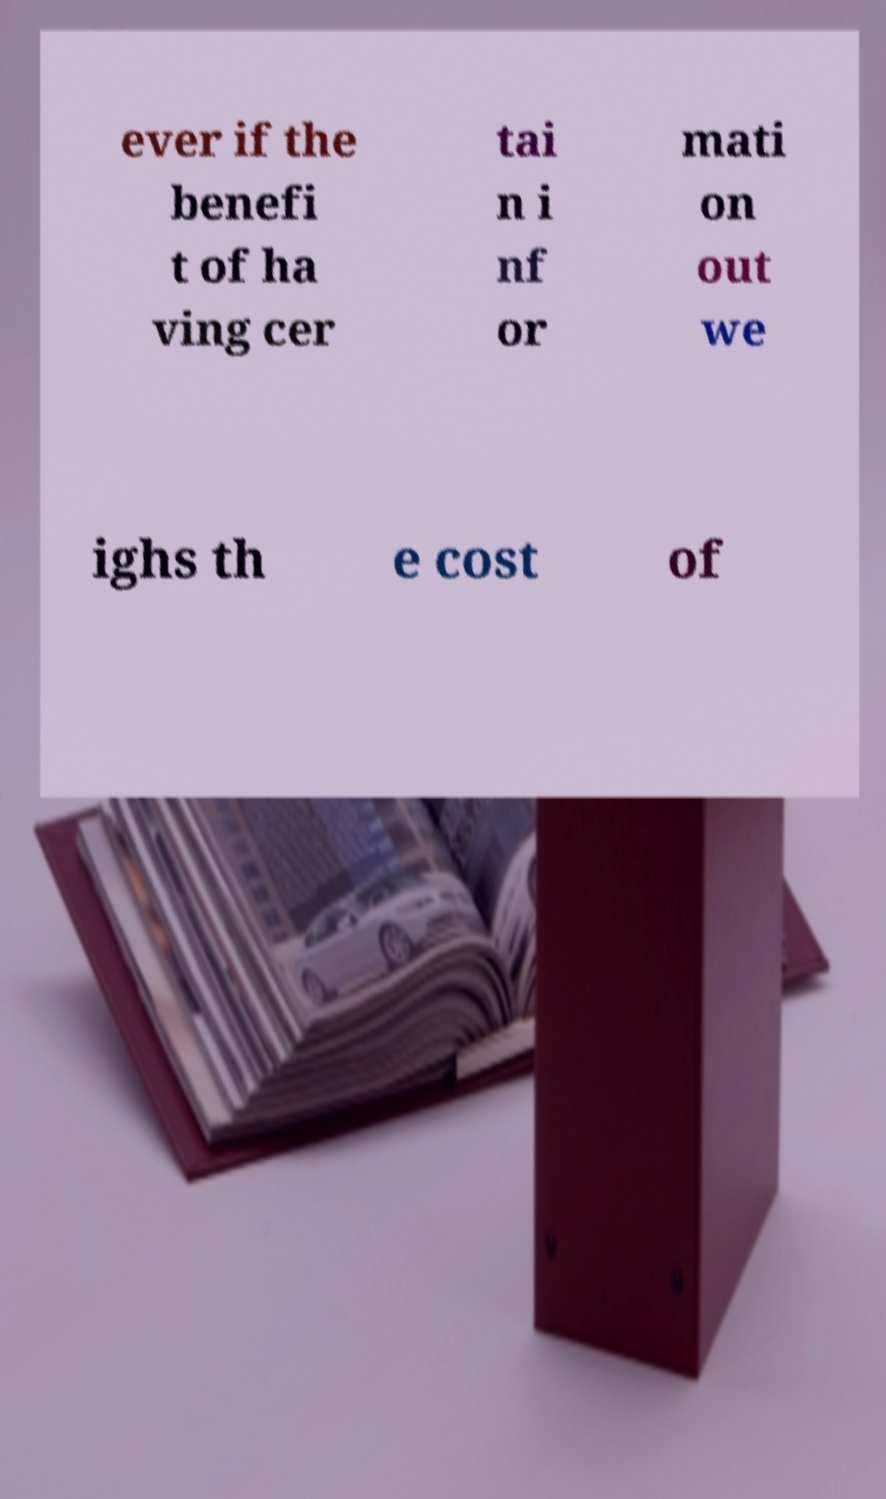Can you read and provide the text displayed in the image?This photo seems to have some interesting text. Can you extract and type it out for me? ever if the benefi t of ha ving cer tai n i nf or mati on out we ighs th e cost of 